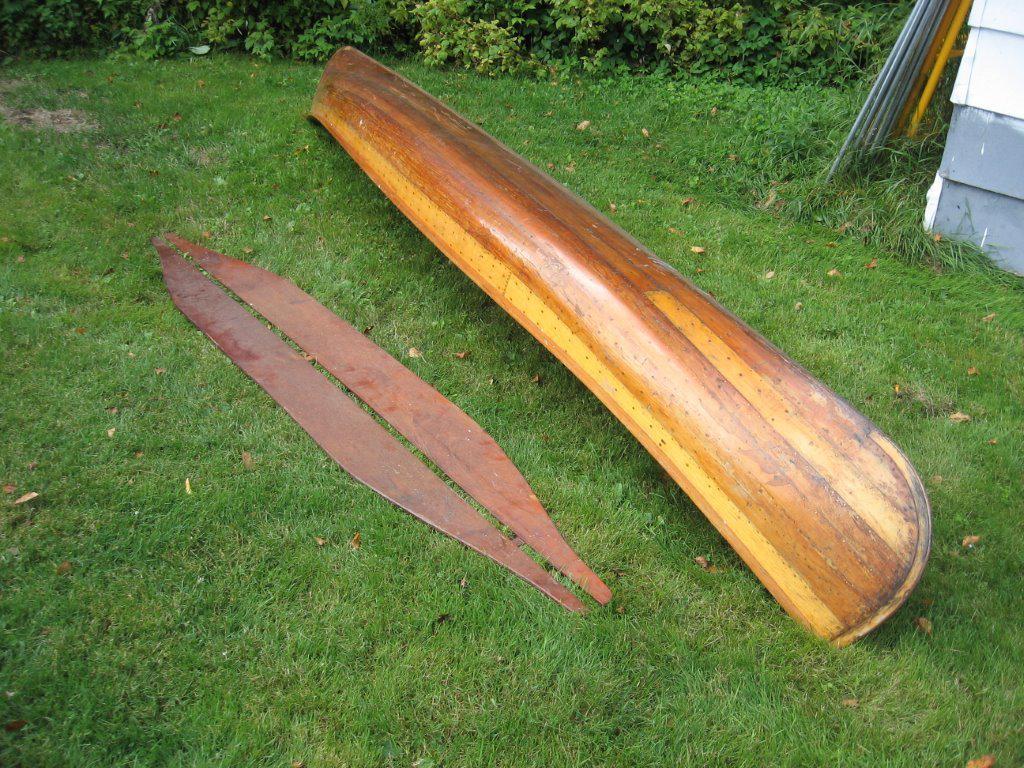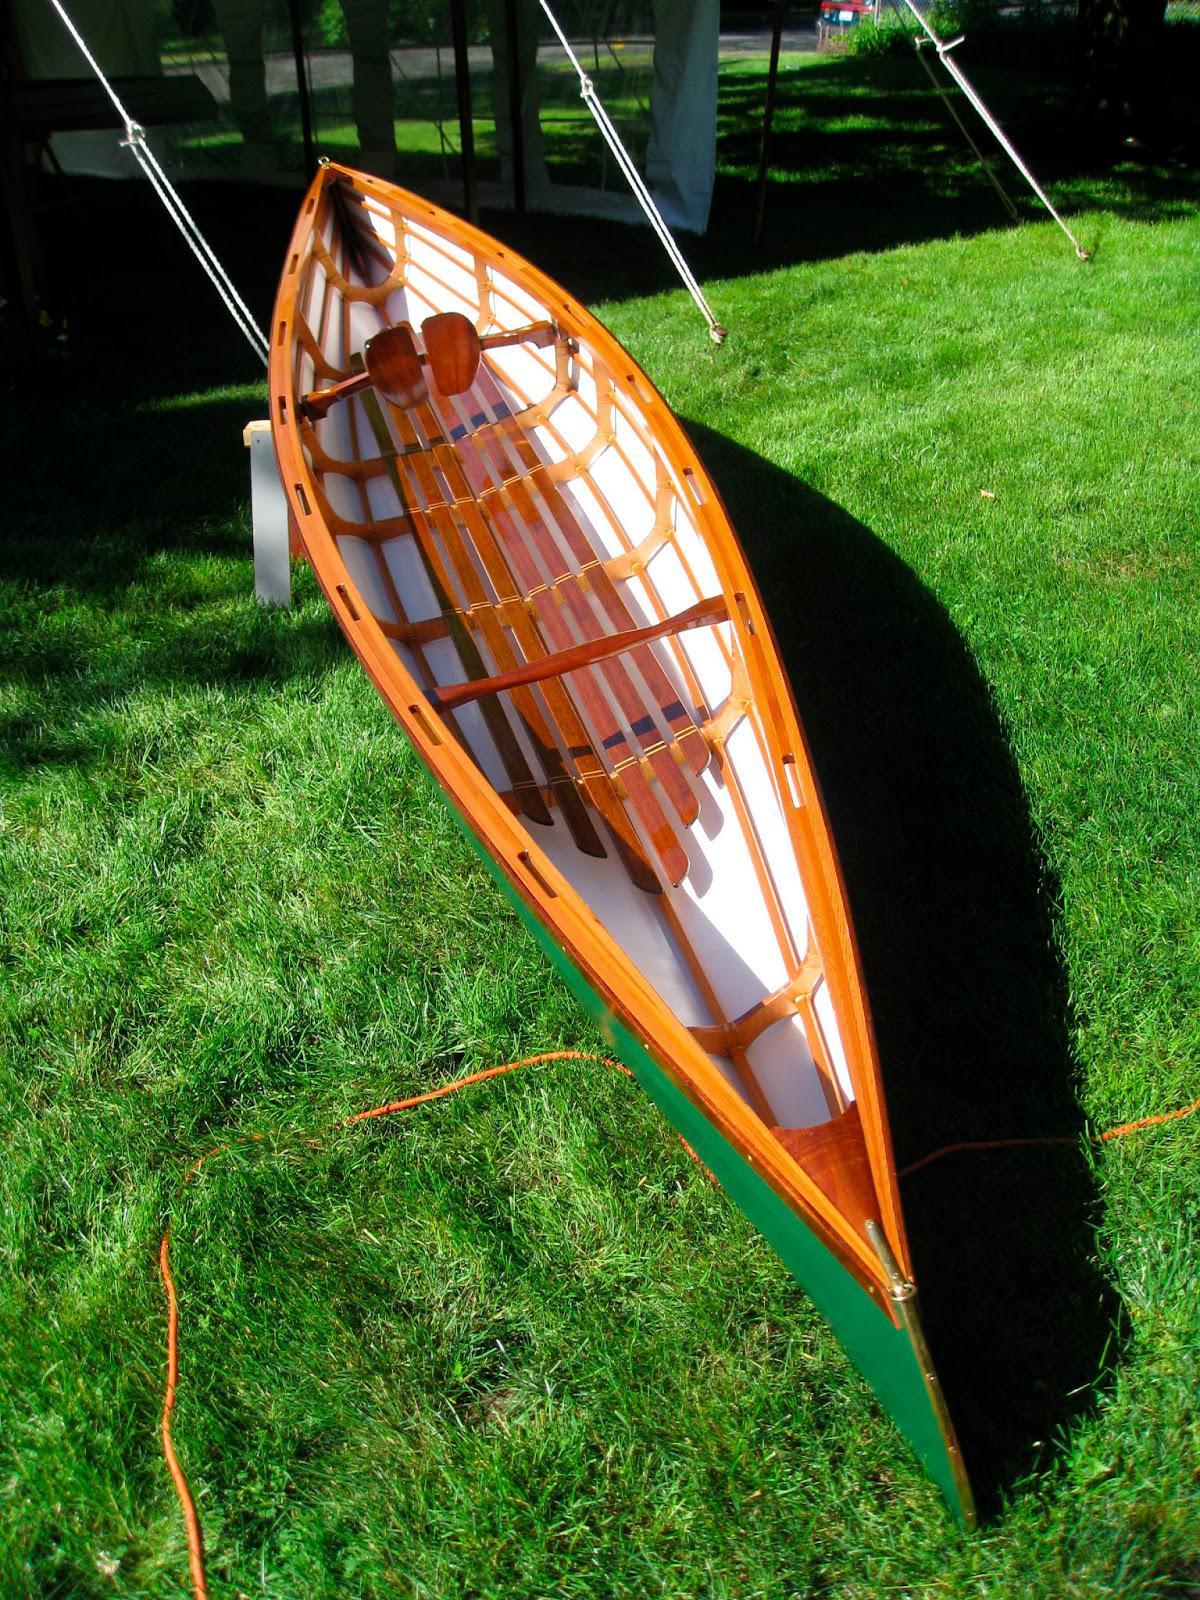The first image is the image on the left, the second image is the image on the right. For the images displayed, is the sentence "One canoe is near water." factually correct? Answer yes or no. No. The first image is the image on the left, the second image is the image on the right. Given the left and right images, does the statement "Two boats sit on the land in the image on the right." hold true? Answer yes or no. No. 